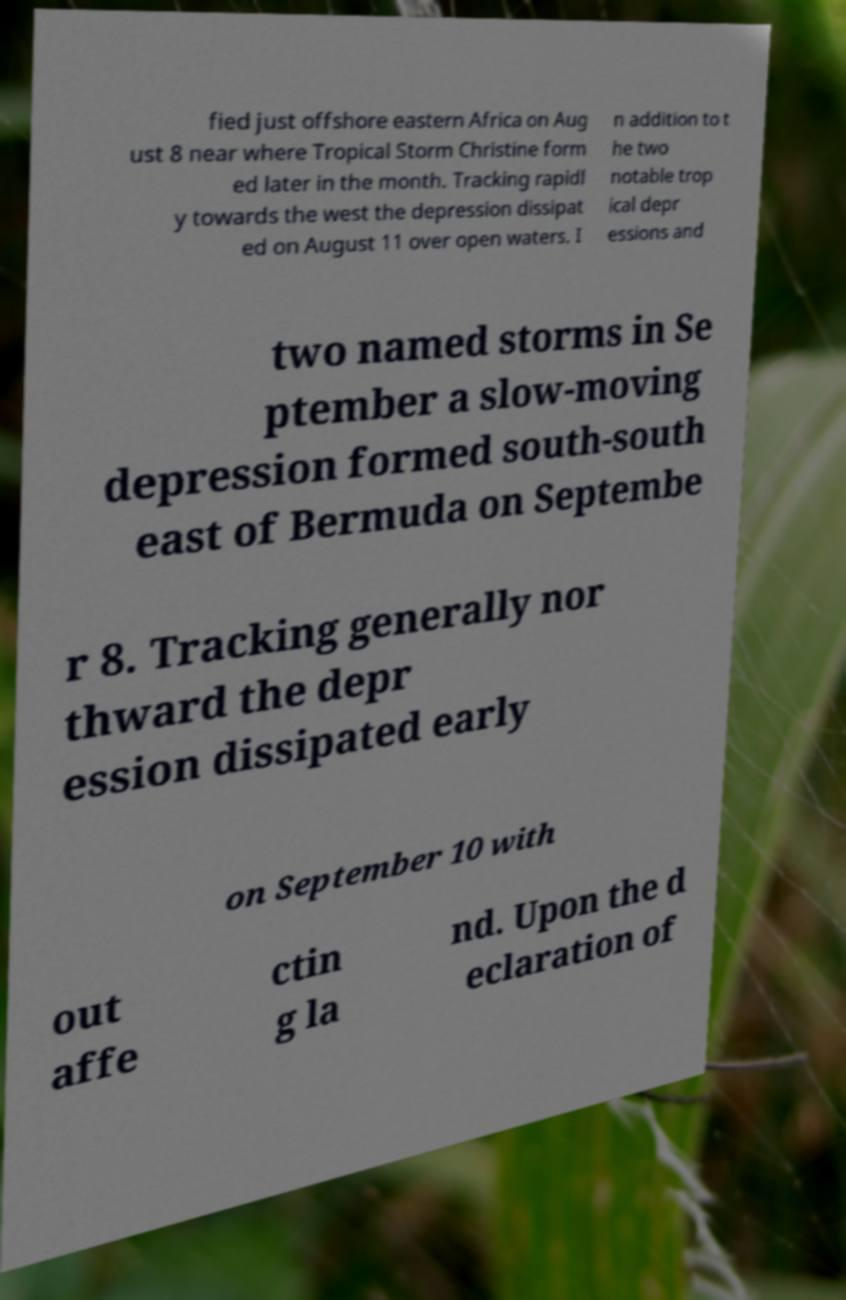There's text embedded in this image that I need extracted. Can you transcribe it verbatim? fied just offshore eastern Africa on Aug ust 8 near where Tropical Storm Christine form ed later in the month. Tracking rapidl y towards the west the depression dissipat ed on August 11 over open waters. I n addition to t he two notable trop ical depr essions and two named storms in Se ptember a slow-moving depression formed south-south east of Bermuda on Septembe r 8. Tracking generally nor thward the depr ession dissipated early on September 10 with out affe ctin g la nd. Upon the d eclaration of 